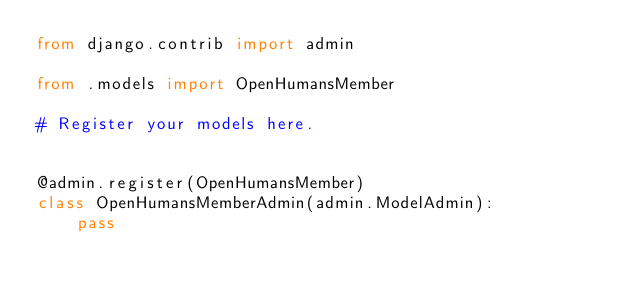<code> <loc_0><loc_0><loc_500><loc_500><_Python_>from django.contrib import admin

from .models import OpenHumansMember

# Register your models here.


@admin.register(OpenHumansMember)
class OpenHumansMemberAdmin(admin.ModelAdmin):
    pass
</code> 